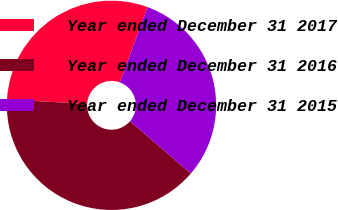<chart> <loc_0><loc_0><loc_500><loc_500><pie_chart><fcel>Year ended December 31 2017<fcel>Year ended December 31 2016<fcel>Year ended December 31 2015<nl><fcel>29.7%<fcel>39.6%<fcel>30.69%<nl></chart> 